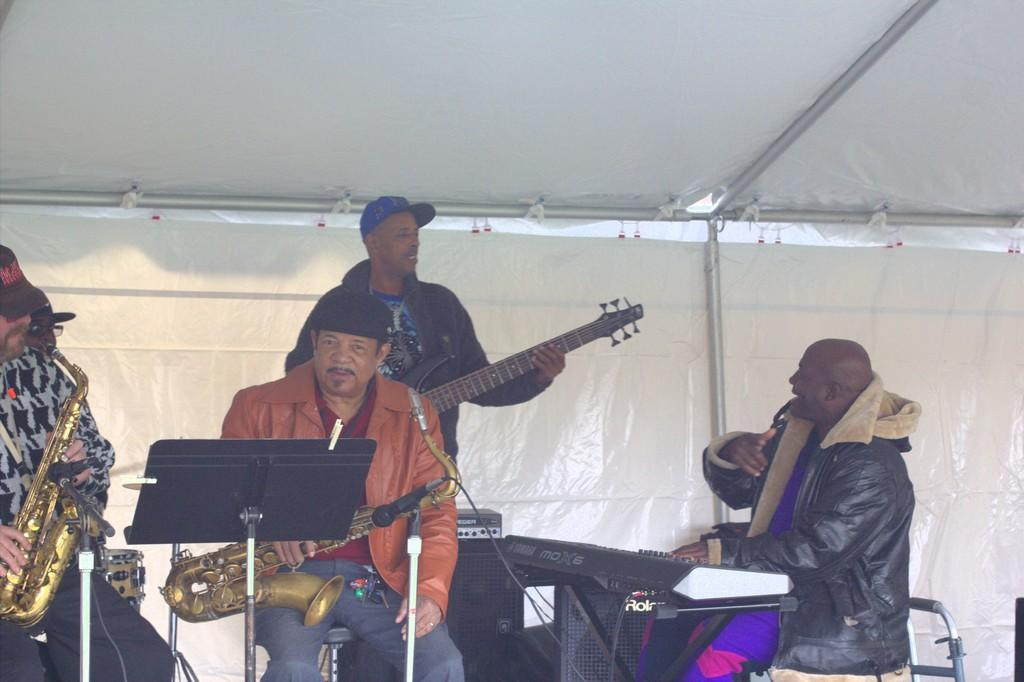What is happening in the image? There is a group of people in the image, and they are holding musical instruments. What can be seen behind the group of people? The background wall is white in color. What type of shoe is being used as a percussion instrument in the image? There is no shoe present in the image, and no musical instruments are being used as percussion instruments. 